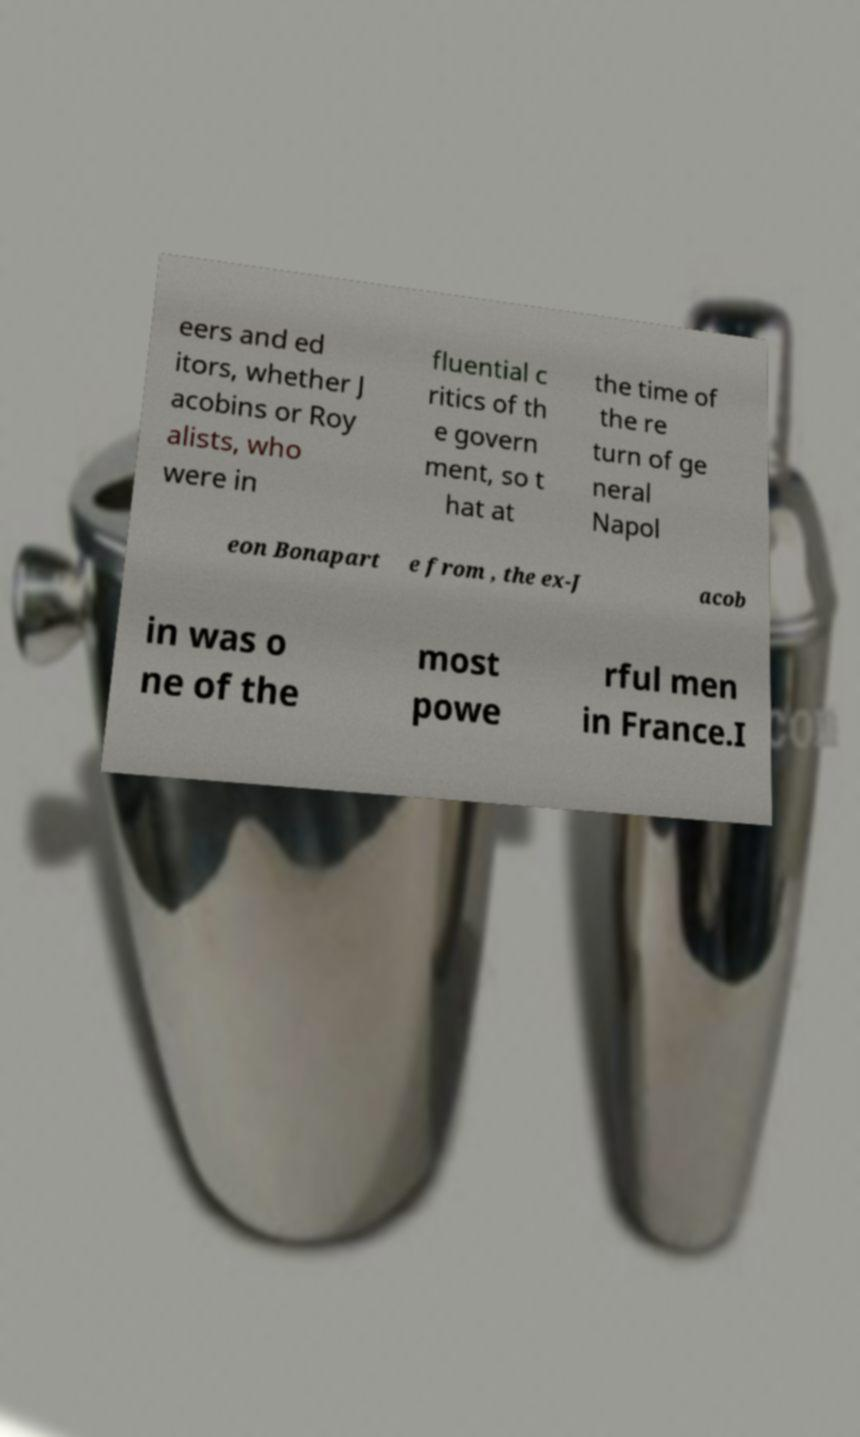Could you assist in decoding the text presented in this image and type it out clearly? eers and ed itors, whether J acobins or Roy alists, who were in fluential c ritics of th e govern ment, so t hat at the time of the re turn of ge neral Napol eon Bonapart e from , the ex-J acob in was o ne of the most powe rful men in France.I 